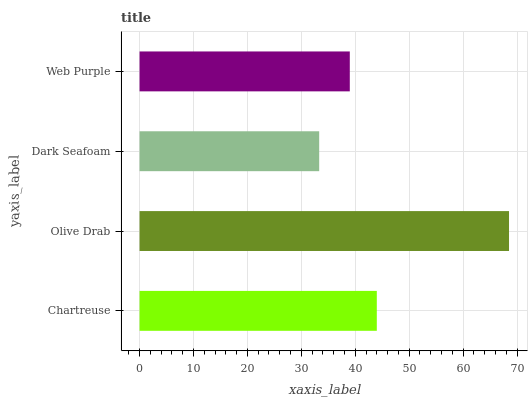Is Dark Seafoam the minimum?
Answer yes or no. Yes. Is Olive Drab the maximum?
Answer yes or no. Yes. Is Olive Drab the minimum?
Answer yes or no. No. Is Dark Seafoam the maximum?
Answer yes or no. No. Is Olive Drab greater than Dark Seafoam?
Answer yes or no. Yes. Is Dark Seafoam less than Olive Drab?
Answer yes or no. Yes. Is Dark Seafoam greater than Olive Drab?
Answer yes or no. No. Is Olive Drab less than Dark Seafoam?
Answer yes or no. No. Is Chartreuse the high median?
Answer yes or no. Yes. Is Web Purple the low median?
Answer yes or no. Yes. Is Web Purple the high median?
Answer yes or no. No. Is Dark Seafoam the low median?
Answer yes or no. No. 